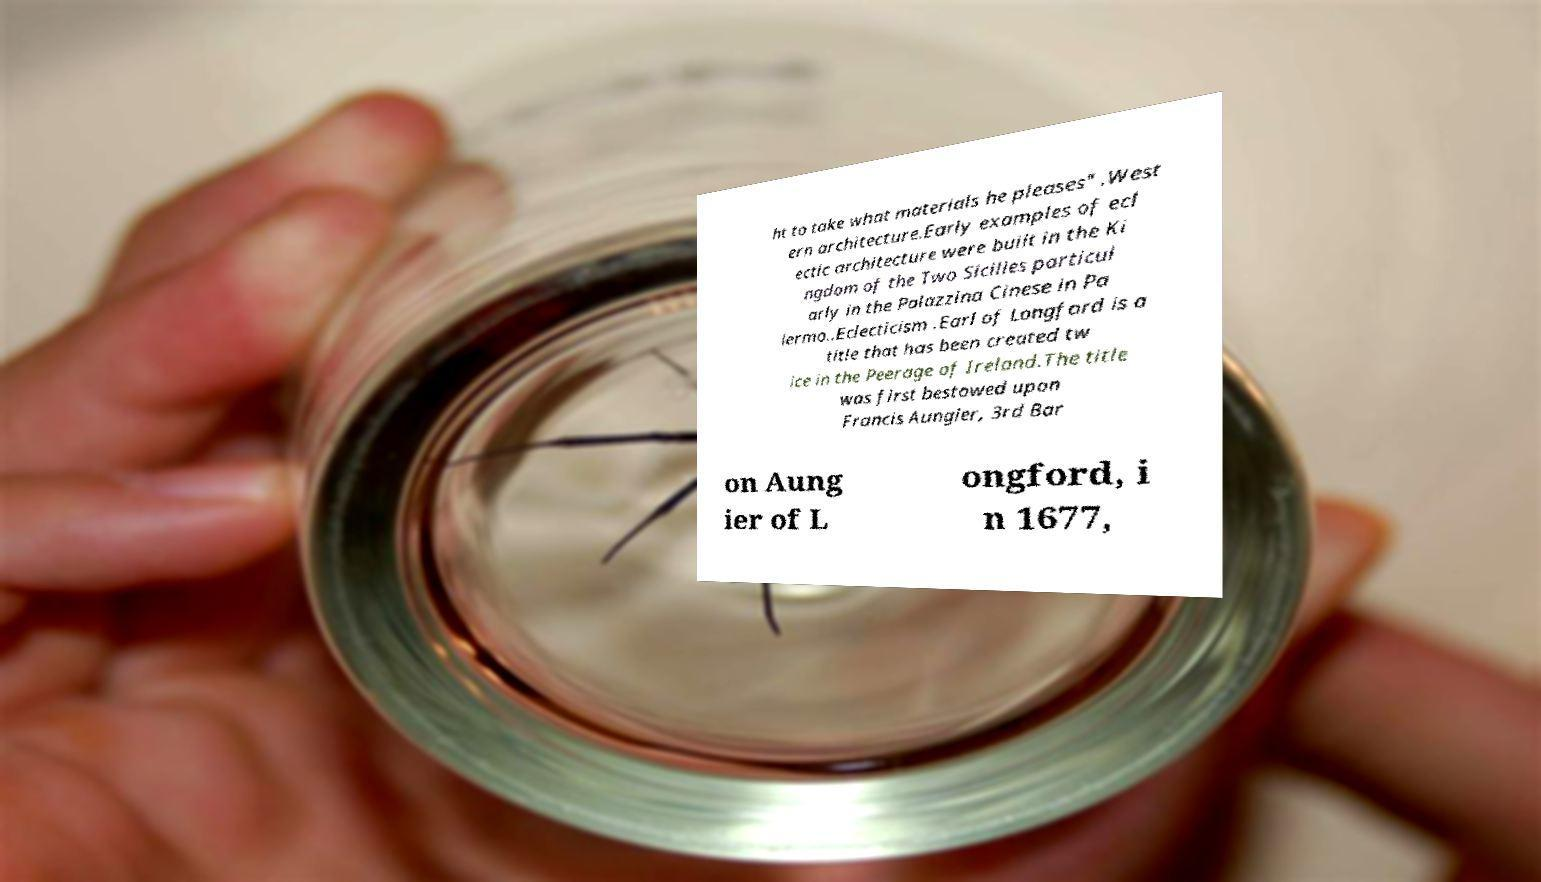Can you accurately transcribe the text from the provided image for me? ht to take what materials he pleases" .West ern architecture.Early examples of ecl ectic architecture were built in the Ki ngdom of the Two Sicilies particul arly in the Palazzina Cinese in Pa lermo..Eclecticism .Earl of Longford is a title that has been created tw ice in the Peerage of Ireland.The title was first bestowed upon Francis Aungier, 3rd Bar on Aung ier of L ongford, i n 1677, 